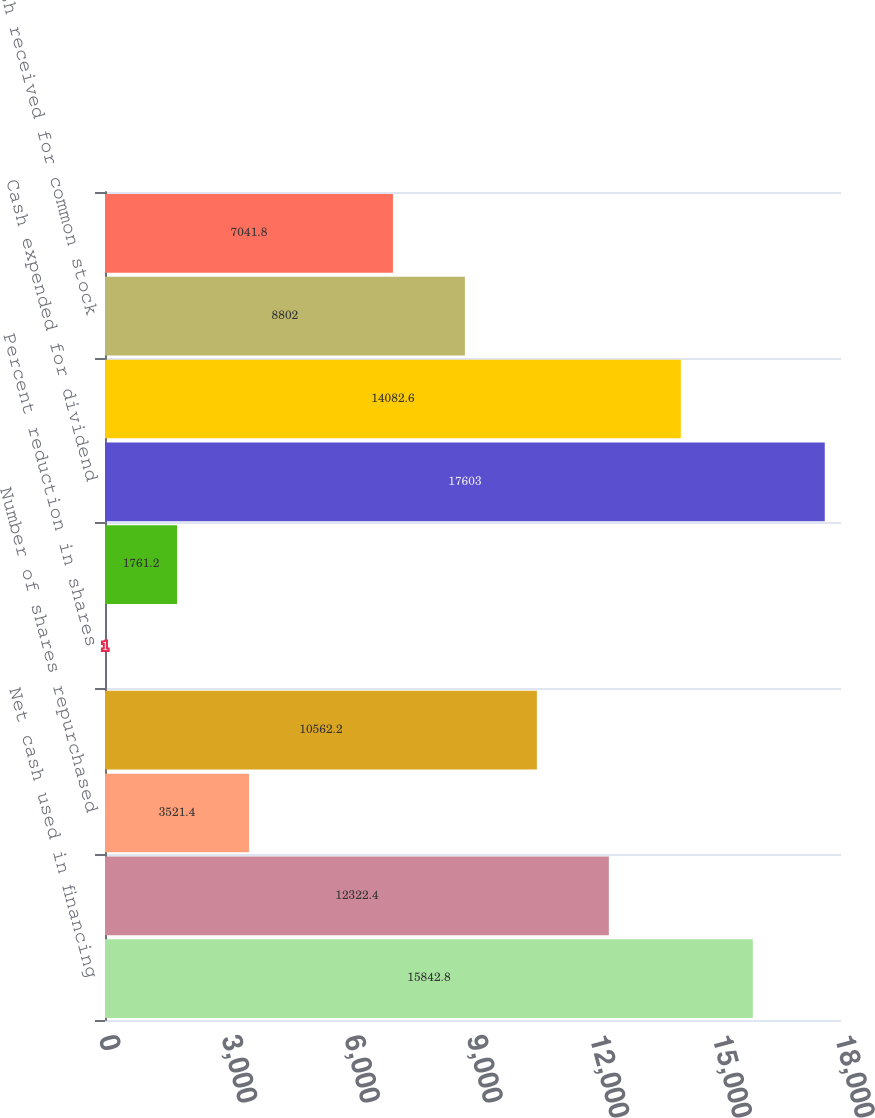<chart> <loc_0><loc_0><loc_500><loc_500><bar_chart><fcel>Net cash used in financing<fcel>Cash expended for shares<fcel>Number of shares repurchased<fcel>Shares outstanding at year-end<fcel>Percent reduction in shares<fcel>Dividends declared per share<fcel>Cash expended for dividend<fcel>Net borrowings (repayments) of<fcel>Cash received for common stock<fcel>Other financing activities<nl><fcel>15842.8<fcel>12322.4<fcel>3521.4<fcel>10562.2<fcel>1<fcel>1761.2<fcel>17603<fcel>14082.6<fcel>8802<fcel>7041.8<nl></chart> 